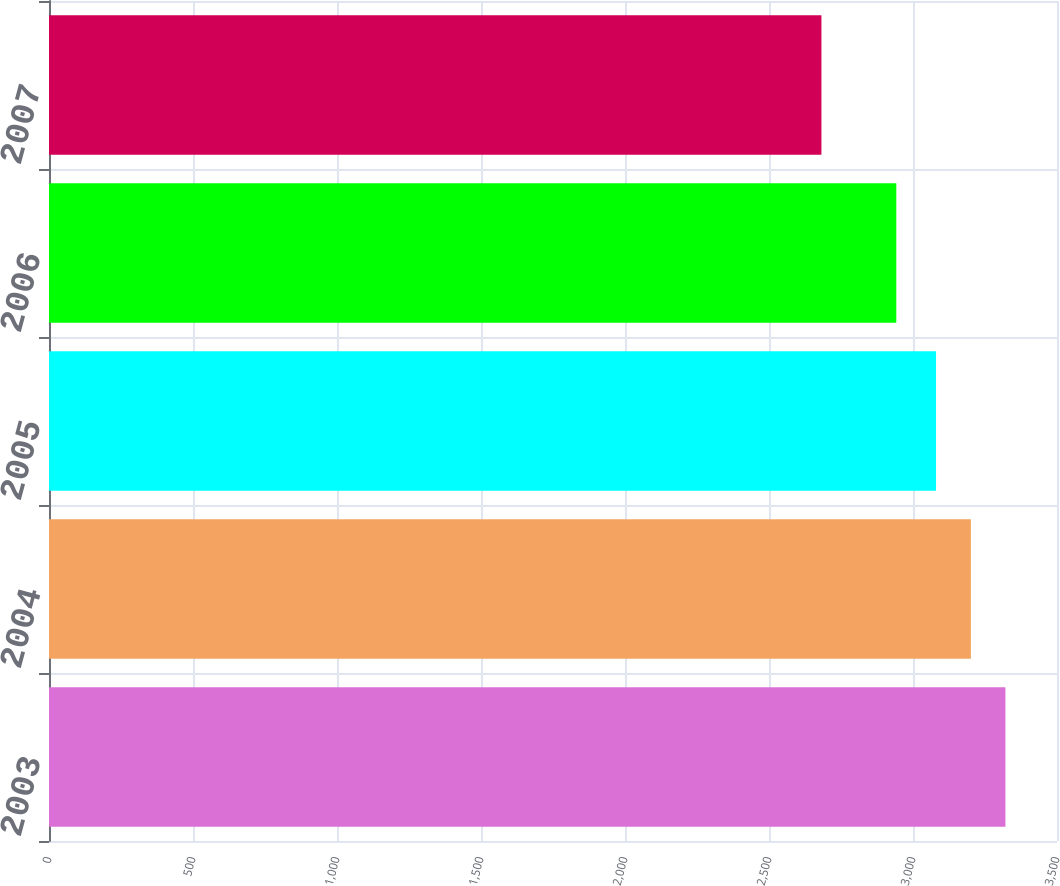Convert chart. <chart><loc_0><loc_0><loc_500><loc_500><bar_chart><fcel>2003<fcel>2004<fcel>2005<fcel>2006<fcel>2007<nl><fcel>3321<fcel>3201<fcel>3080<fcel>2942<fcel>2682<nl></chart> 